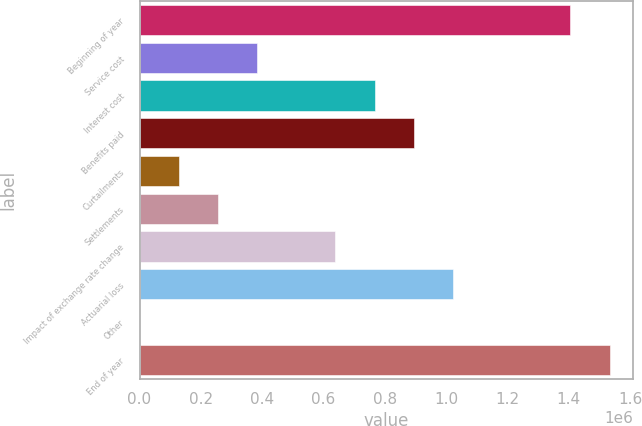Convert chart. <chart><loc_0><loc_0><loc_500><loc_500><bar_chart><fcel>Beginning of year<fcel>Service cost<fcel>Interest cost<fcel>Benefits paid<fcel>Curtailments<fcel>Settlements<fcel>Impact of exchange rate change<fcel>Actuarial loss<fcel>Other<fcel>End of year<nl><fcel>1.40549e+06<fcel>383348<fcel>766651<fcel>894419<fcel>127813<fcel>255580<fcel>638884<fcel>1.02219e+06<fcel>45<fcel>1.53326e+06<nl></chart> 